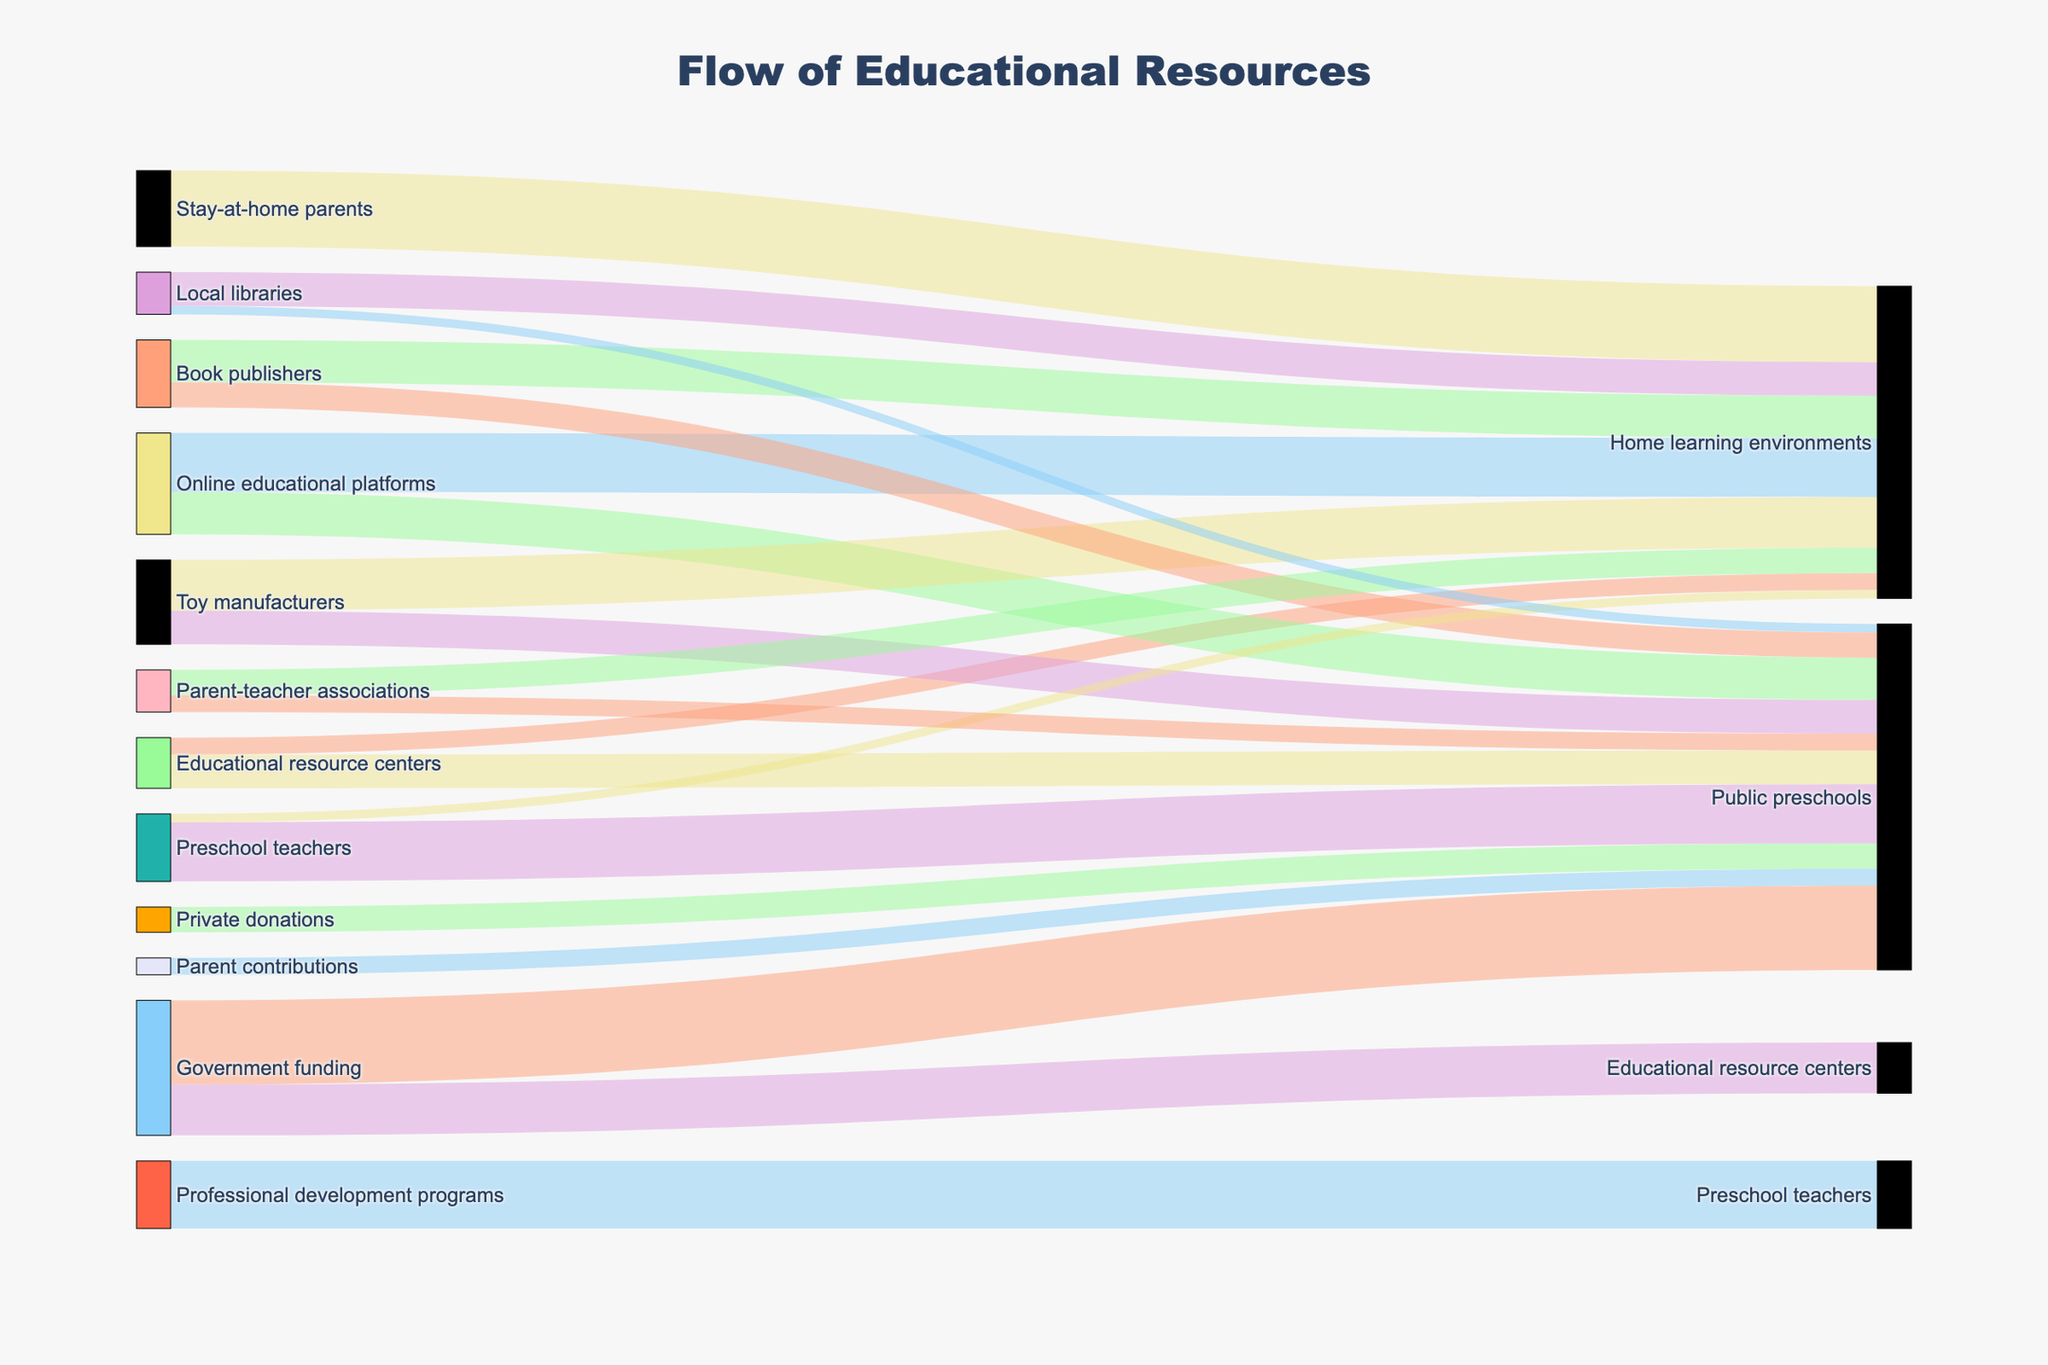what is the title of the Sankey diagram? The title is usually displayed at the top of the figure, offering a summary of the overall visual representation. The title here provides context to what the figure is about.
Answer: Flow of Educational Resources Which source contributes the most to Public preschools? From the diagram, observe all the links flowing into "Public preschools" and identify the source with the highest value. "Government funding" contributes 50, which is the largest value.
Answer: Government funding How many educational resources do Online educational platforms contribute in total? Add up the values from "Online educational platforms" to all its targets. Contributions are 25 (to public preschools) + 35 (to home learning environments).
Answer: 60 Which environment receives the higher number of resources from Educational resource centers, Home learning environments, or Public preschools? Compare the values of resources flowing from "Educational resource centers" to both "Home learning environments" and "Public preschools". Home learning gets 10, and Public preschools get 20.
Answer: Public preschools Is there any resource type that is solely contributing to one type of environment? Examine if any resource type shown in the sources is contributing resources exclusively to either public preschools or home learning environments. Both toy manufacturers and book publishers contribute to both.
Answer: No How many sources in total contribute to Public preschools? Count all unique sources that have arrows pointing to "Public preschools". These are Government funding, Private donations, Parent contributions, Educational resource centers, Online educational platforms, Toy manufacturers, Book publishers, Parent-teacher associations, Local libraries, and Preschool teachers.
Answer: Nine Which source supplies the highest resources to Home learning environments? Look at all connections leading to Home learning environments and find the source with the highest value. Stay-at-home parents contribute the most with 45.
Answer: Stay-at-home parents How do the contributions from Parent-teacher associations differ between Public preschools and Home learning environments? Check the values of resources flowing from Parent-teacher associations to both types of environments. They contribute 10 to public preschools and 15 to home learning. Subtracting these, the difference is 15 - 10.
Answer: 5 Which source contributes more to Home learning environments, Educational resource centers, or Local libraries? Look at the contributions from both Educational resource centers (10) and Local libraries (20) to Home learning environments.
Answer: Local libraries What is the contribution from Professional development programs to Preschool teachers compared to the contribution from Preschool teachers to Public preschools? Check the values of resources from Professional development programs to Preschool teachers and Preschool teachers to Public preschools. Professional development contributes 40, teachers contribute 35.
Answer: Professional development programs contribute more 